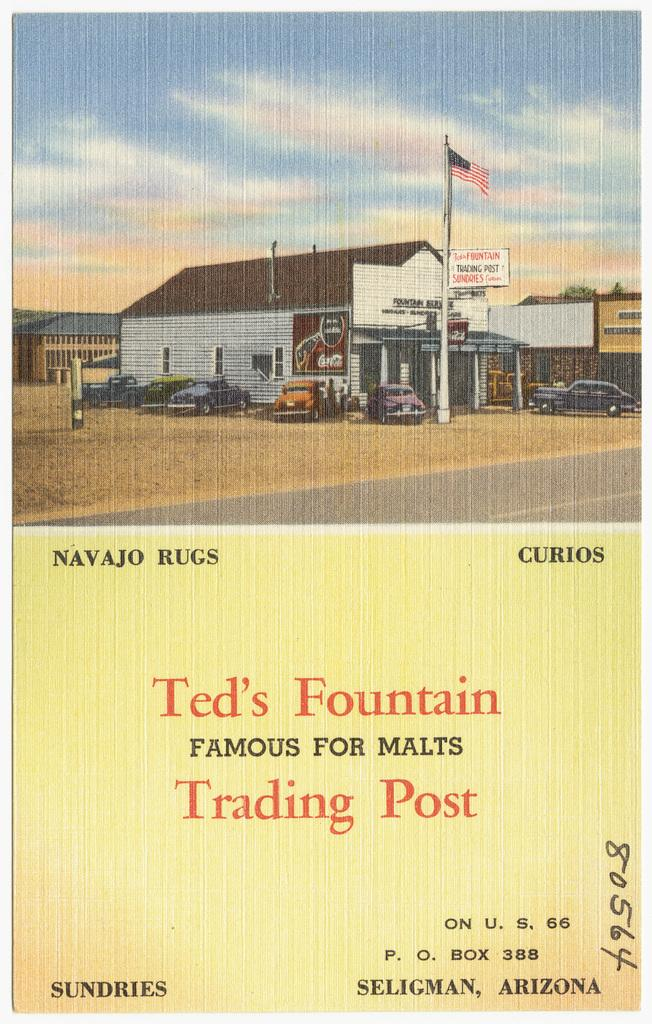<image>
Share a concise interpretation of the image provided. the front of a poster that says 'ted's fountain famous for malts trading post' 